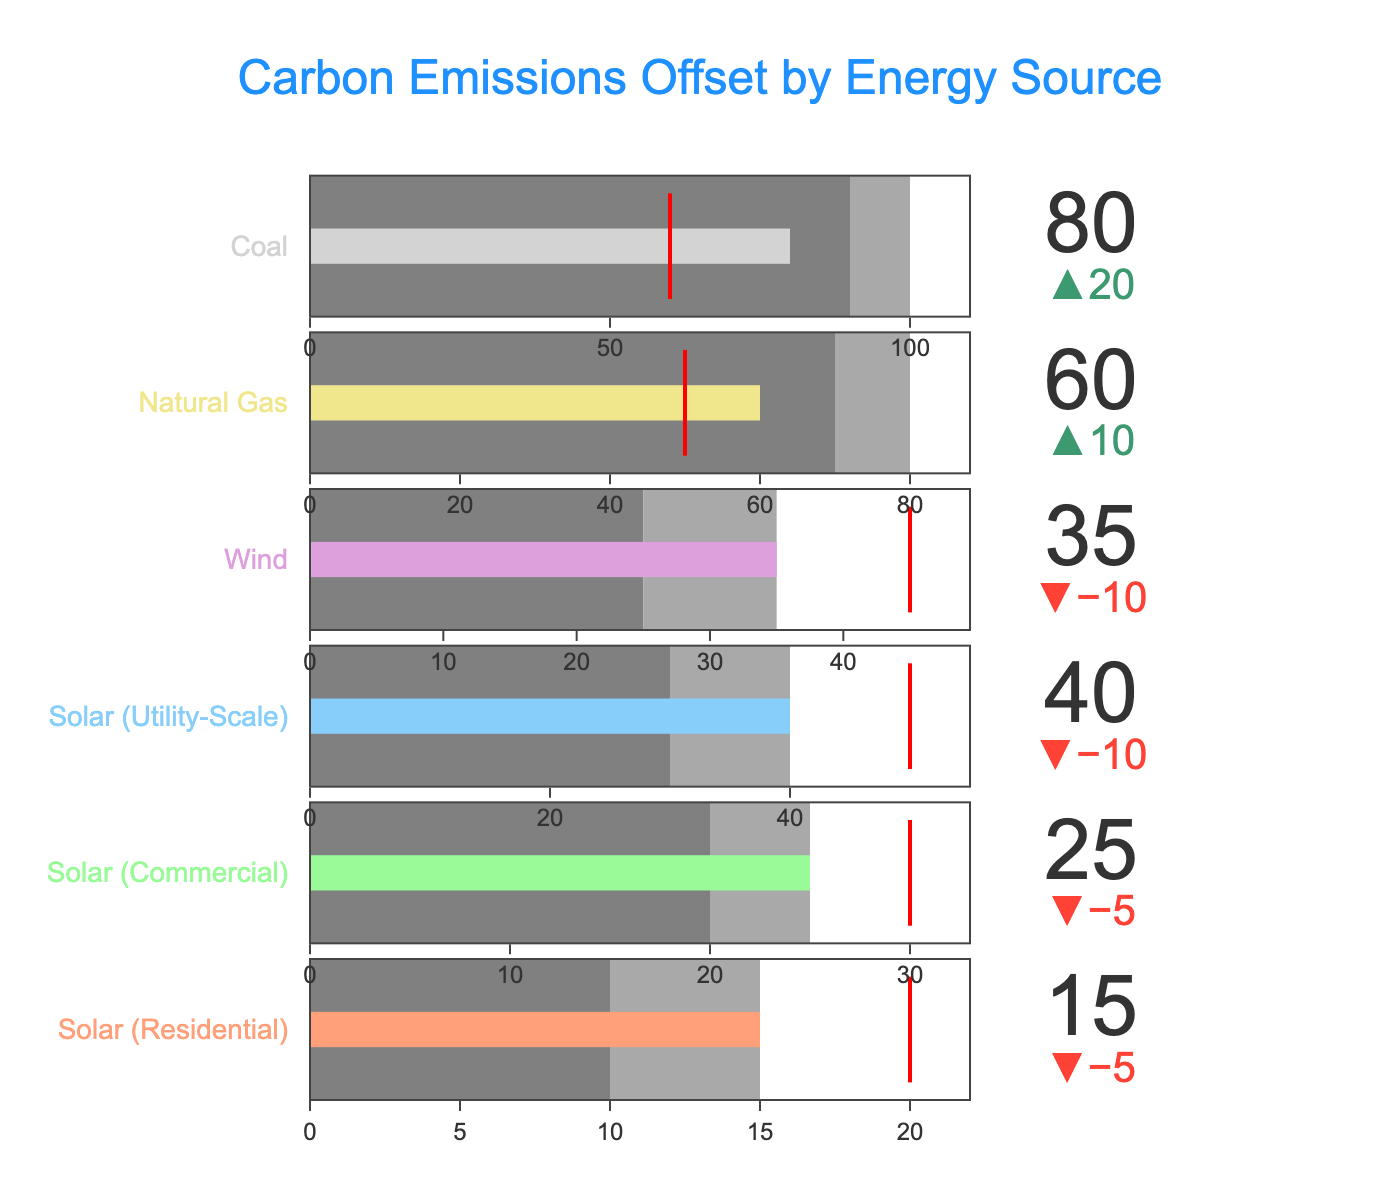what is the title of the bullet chart? The title is displayed prominently at the top of the chart in large blue font. It reads "Carbon Emissions Offset by Energy Source."
Answer: Carbon Emissions Offset by Energy Source how many categories are displayed in the figure? Each category is given a separate bullet chart, and there are six bullet charts.
Answer: Six which category has the highest target value for carbon offsets? Observing the target values shown in red thresholds, the highest is "Solar (Utility-Scale)" with a target of 50.
Answer: Solar (Utility-Scale) is "solar (residential)" achieving its target value? The actual value for "Solar (Residential)" is 15, and its target value is 20. So, it has not achieved its target.
Answer: No what is the actual carbon offset value for coal energy? The actual value for coal is explicitly marked and found as 80 in the chart.
Answer: 80 how much more does the natural gas offset need to meet its target? "Natural Gas" has an actual value of 60 and a target of 50. Since the actual offset is greater than the target, no additional offset is needed.
Answer: 0 which renewable energy source comes closest to hitting its target? The difference between actual and target values is smallest for "Solar (Commercial)" with actual 25 and target 30, resulting in a difference of 5.
Answer: Solar (Commercial) what is the total carbon emissions offset by all solar energy implementations? Adding up the actual values for "Solar (Residential)" (15), "Solar (Commercial)" (25), and "Solar (Utility-Scale)" (40): 15 + 25 + 40 = 80.
Answer: 80 compare the actual carbon offsets between wind and coal energy sources. Which has higher value? "Wind" has an actual value of 35, while "Coal" has an actual value of 80. Therefore, "Coal" has a higher value.
Answer: Coal does any fossil fuel category meet its carbon offset target? By examining "Natural Gas" and "Coal", we see their actual values (60 and 80) both exceed their targets (50 and 60). Thus, each target is met.
Answer: Yes 